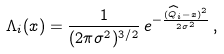<formula> <loc_0><loc_0><loc_500><loc_500>\Lambda _ { i } ( x ) = \frac { 1 } { ( 2 \pi \sigma ^ { 2 } ) ^ { 3 / 2 } } \, e ^ { - \frac { ( \widehat { Q } _ { i } - x ) ^ { 2 } } { 2 \sigma ^ { 2 } } } \, ,</formula> 